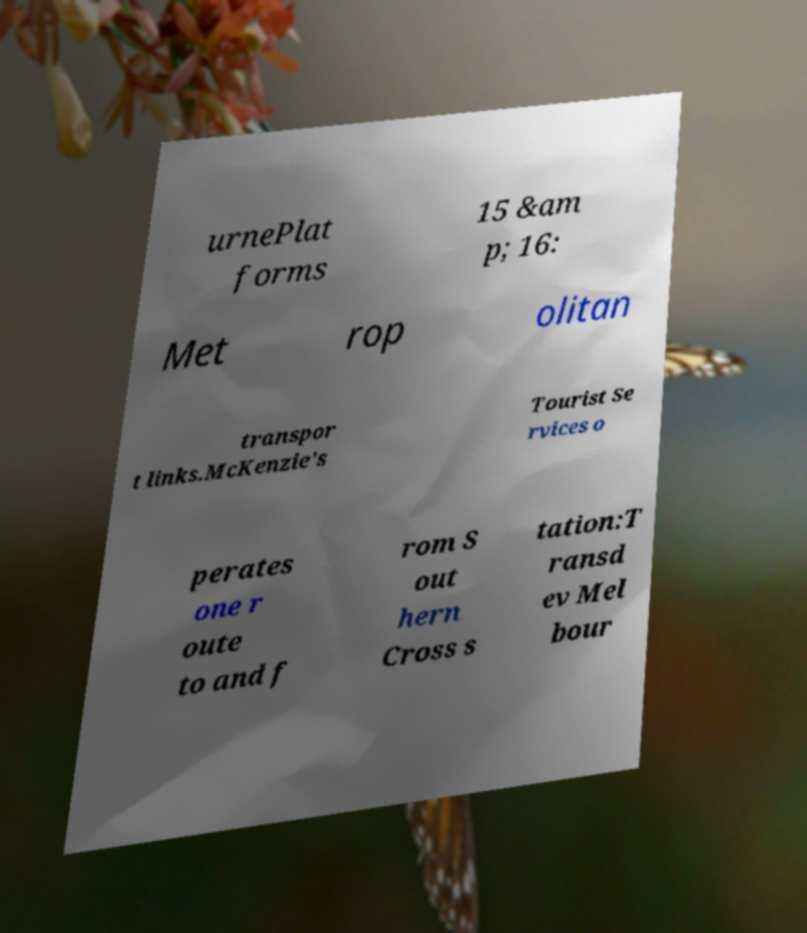Can you accurately transcribe the text from the provided image for me? urnePlat forms 15 &am p; 16: Met rop olitan transpor t links.McKenzie's Tourist Se rvices o perates one r oute to and f rom S out hern Cross s tation:T ransd ev Mel bour 